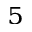Convert formula to latex. <formula><loc_0><loc_0><loc_500><loc_500>^ { 5 }</formula> 